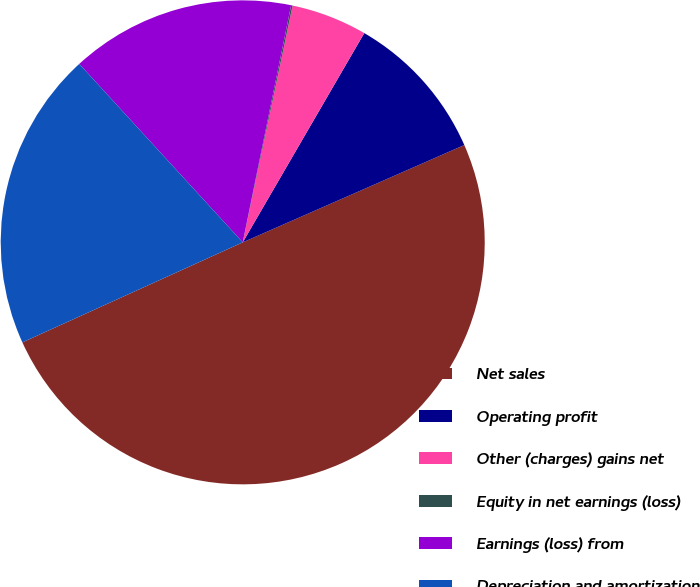<chart> <loc_0><loc_0><loc_500><loc_500><pie_chart><fcel>Net sales<fcel>Operating profit<fcel>Other (charges) gains net<fcel>Equity in net earnings (loss)<fcel>Earnings (loss) from<fcel>Depreciation and amortization<nl><fcel>49.81%<fcel>10.04%<fcel>5.07%<fcel>0.1%<fcel>15.01%<fcel>19.98%<nl></chart> 